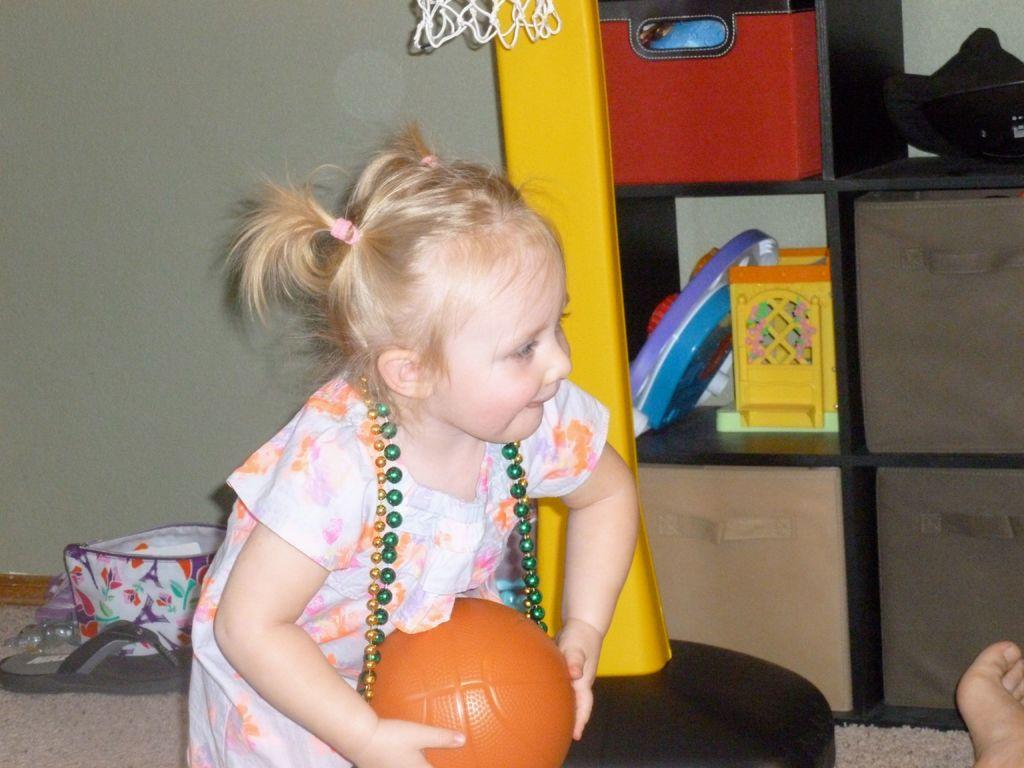Who is the main subject in the image? There is a girl in the image. What is the girl holding in the image? The girl is holding a ball. Can you describe any other objects visible in the image? Yes, there are objects visible in the image. What type of footwear can be seen in the image? There is footwear in the image. What time does the girl's ring indicate in the image? There is no ring present in the image, so it is not possible to determine the time. 